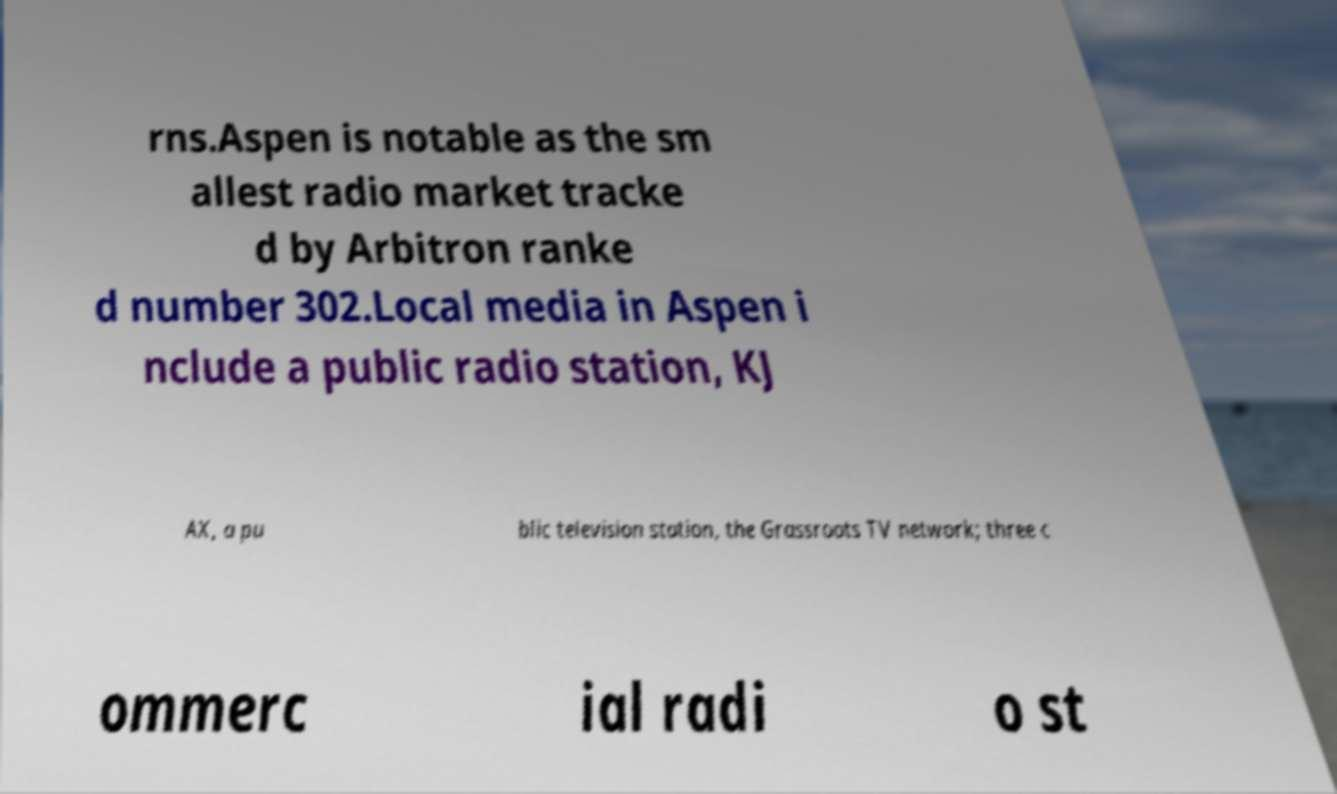For documentation purposes, I need the text within this image transcribed. Could you provide that? rns.Aspen is notable as the sm allest radio market tracke d by Arbitron ranke d number 302.Local media in Aspen i nclude a public radio station, KJ AX, a pu blic television station, the Grassroots TV network; three c ommerc ial radi o st 